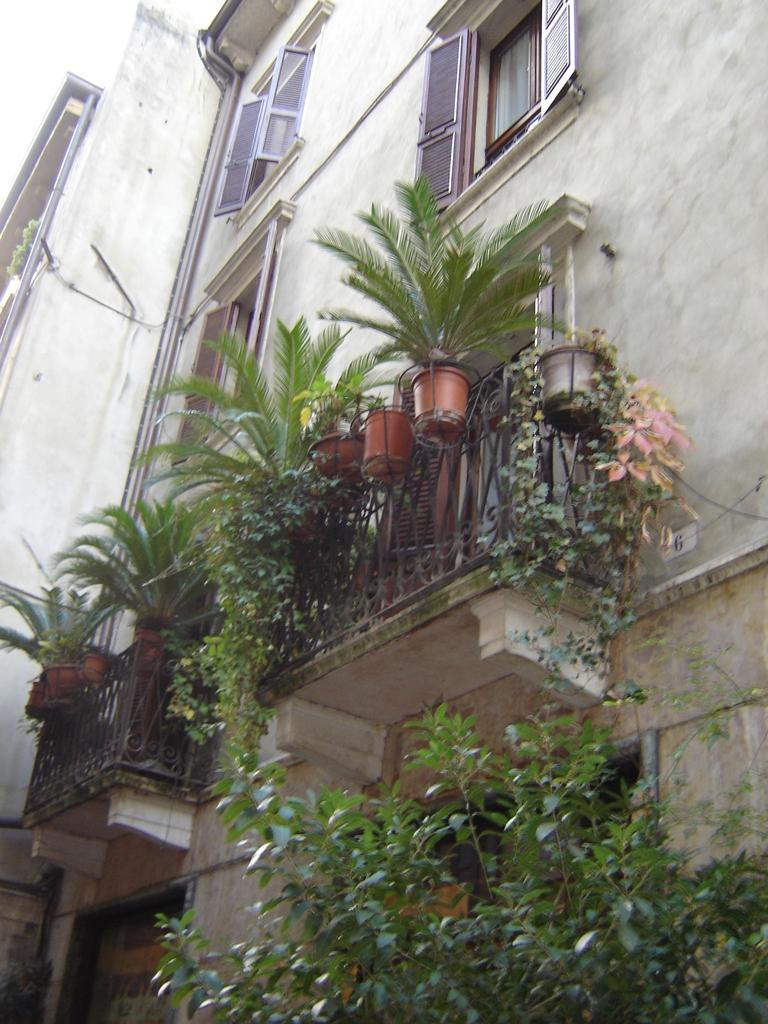What is the main structure visible in the image? There is a building wall in the image. What feature can be seen on the building wall? The building wall has a balcony grill. What type of objects are attached to the building wall? There are many plant pots on the wall. What is visible above the building wall? Above the wall, there are glass windows visible. How many sponges are placed on the balcony grill in the image? There are no sponges present on the balcony grill in the image. What type of part is missing from the building wall in the image? There is no indication of any missing parts in the building wall in the image. 